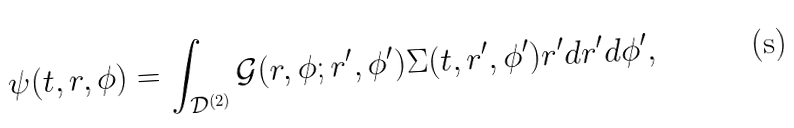<formula> <loc_0><loc_0><loc_500><loc_500>\psi ( t , r , \phi ) = \int _ { \mathcal { D } ^ { ( 2 ) } } \mathcal { G } ( r , \phi ; r ^ { \prime } , \phi ^ { \prime } ) \Sigma ( t , r ^ { \prime } , \phi ^ { \prime } ) r ^ { \prime } d r ^ { \prime } d \phi ^ { \prime } ,</formula> 